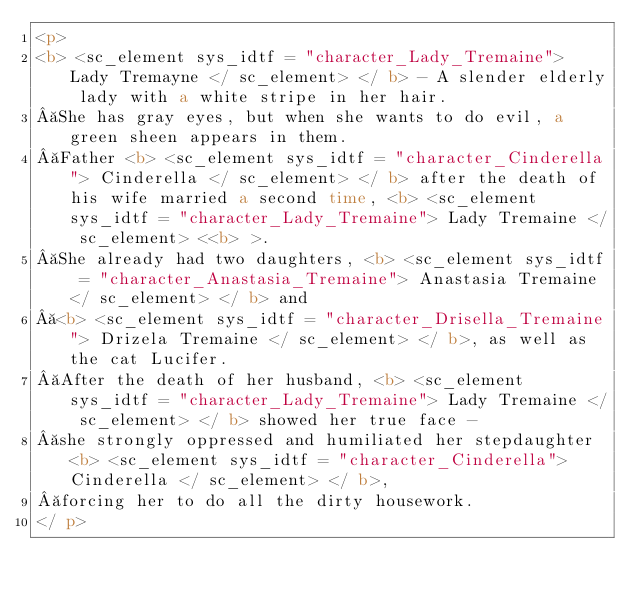Convert code to text. <code><loc_0><loc_0><loc_500><loc_500><_HTML_><p>
<b> <sc_element sys_idtf = "character_Lady_Tremaine"> Lady Tremayne </ sc_element> </ b> - A slender elderly lady with a white stripe in her hair.
 She has gray eyes, but when she wants to do evil, a green sheen appears in them.
 Father <b> <sc_element sys_idtf = "character_Cinderella"> Cinderella </ sc_element> </ b> after the death of his wife married a second time, <b> <sc_element sys_idtf = "character_Lady_Tremaine"> Lady Tremaine </ sc_element> <<b> >.
 She already had two daughters, <b> <sc_element sys_idtf = "character_Anastasia_Tremaine"> Anastasia Tremaine </ sc_element> </ b> and
 <b> <sc_element sys_idtf = "character_Drisella_Tremaine"> Drizela Tremaine </ sc_element> </ b>, as well as the cat Lucifer.
 After the death of her husband, <b> <sc_element sys_idtf = "character_Lady_Tremaine"> Lady Tremaine </ sc_element> </ b> showed her true face -
 she strongly oppressed and humiliated her stepdaughter <b> <sc_element sys_idtf = "character_Cinderella"> Cinderella </ sc_element> </ b>,
 forcing her to do all the dirty housework.
</ p></code> 